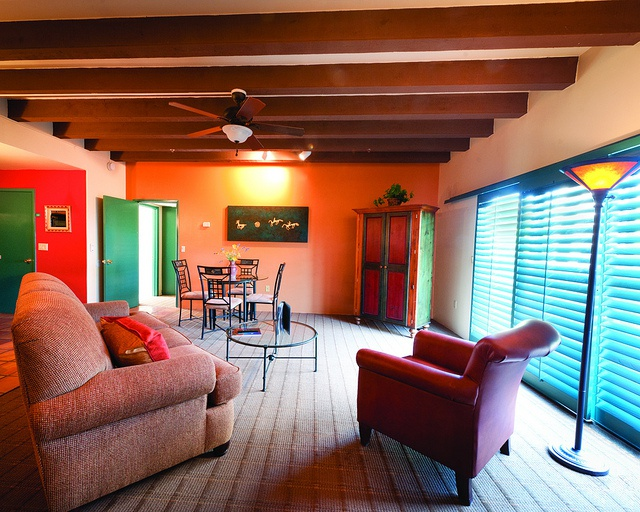Describe the objects in this image and their specific colors. I can see couch in brown, maroon, and lightpink tones, chair in brown, black, maroon, lavender, and violet tones, chair in brown, black, salmon, lightpink, and lavender tones, chair in brown, maroon, lightpink, black, and salmon tones, and chair in brown, lightpink, maroon, salmon, and black tones in this image. 